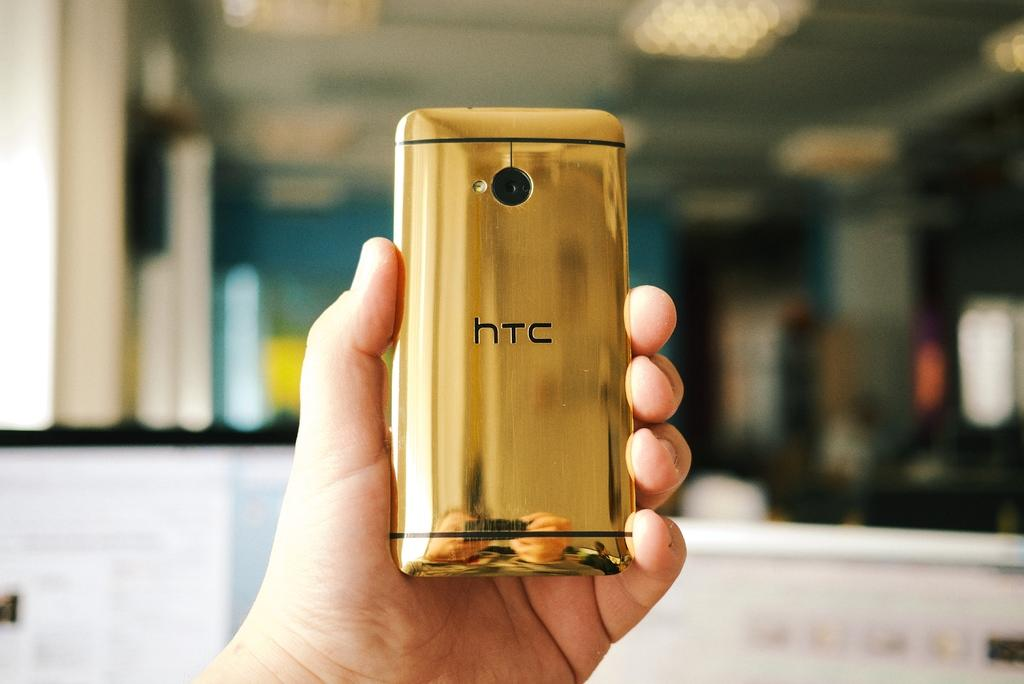Provide a one-sentence caption for the provided image. a golden HTC phone being held up by somebody. 